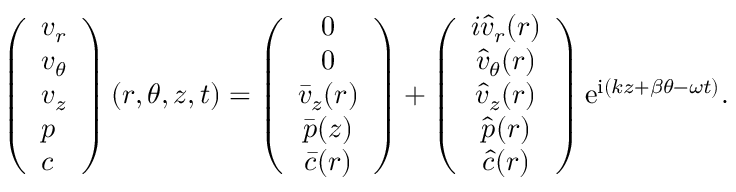Convert formula to latex. <formula><loc_0><loc_0><loc_500><loc_500>\left ( \begin{array} { l } { v _ { r } } \\ { v _ { \theta } } \\ { v _ { z } } \\ { p } \\ { c } \end{array} \right ) ( r , \theta , z , t ) = \left ( \begin{array} { c } { 0 } \\ { 0 } \\ { \bar { v } _ { z } ( r ) } \\ { \bar { p } ( z ) } \\ { \bar { c } ( r ) } \end{array} \right ) + \left ( \begin{array} { c } { i \hat { v } _ { r } ( r ) } \\ { \hat { v } _ { \theta } ( r ) } \\ { \hat { v } _ { z } ( r ) } \\ { \hat { p } ( r ) } \\ { \hat { c } ( r ) } \end{array} \right ) e ^ { i ( k z + \beta \theta - \omega t ) } .</formula> 